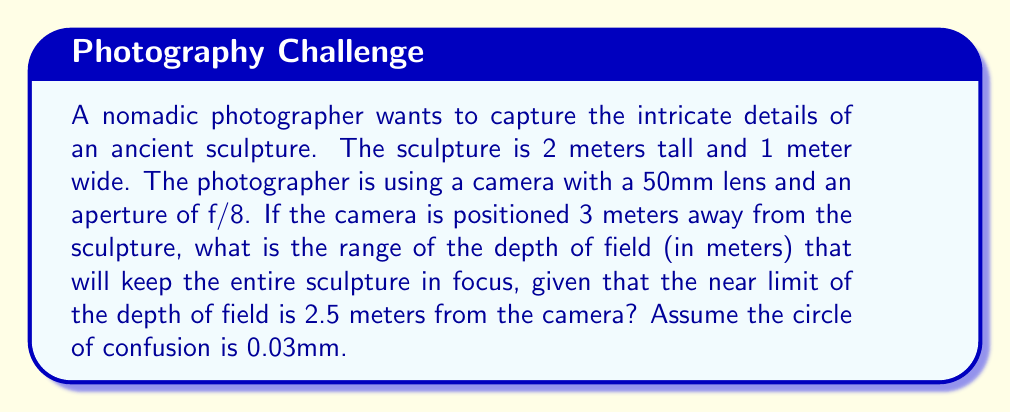Can you answer this question? To solve this problem, we need to calculate the far limit of the depth of field. We'll use the depth of field formula and the given information:

1. Near limit (N) = 2.5 meters
2. Subject distance (U) = 3 meters
3. Focal length (f) = 50mm = 0.05m
4. Aperture (A) = f/8 = 0.05/8 = 0.00625m
5. Circle of confusion (c) = 0.03mm = 0.00003m

Step 1: Calculate the hyperfocal distance (H)
$$H = \frac{f^2}{A \cdot c} + f = \frac{0.05^2}{0.00625 \cdot 0.00003} + 0.05 = 13.39\text{ m}$$

Step 2: Calculate the far limit (F) using the formula:
$$F = \frac{H \cdot U}{H - (U - f)} = \frac{13.39 \cdot 3}{13.39 - (3 - 0.05)} = 3.82\text{ m}$$

Step 3: Calculate the depth of field range
Range = Far limit - Near limit
$$\text{Range} = 3.82 - 2.5 = 1.32\text{ m}$$

This range of 1.32 meters will keep the entire sculpture (2 meters tall, 1 meter wide) in focus, as it extends from 2.5 meters to 3.82 meters from the camera, which covers the sculpture's position at 3 meters.
Answer: 1.32 m 